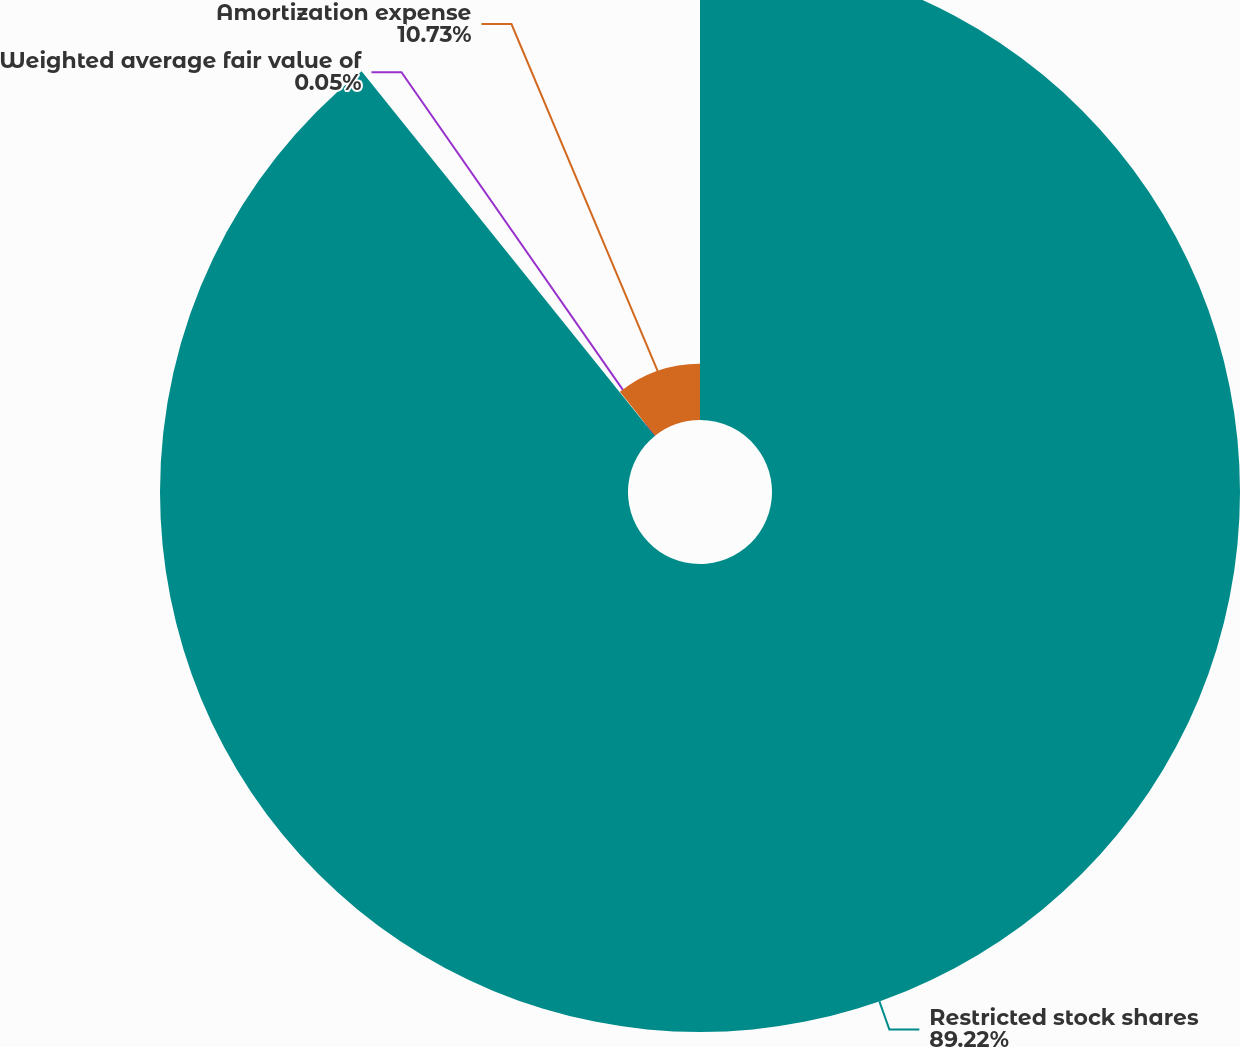Convert chart. <chart><loc_0><loc_0><loc_500><loc_500><pie_chart><fcel>Restricted stock shares<fcel>Weighted average fair value of<fcel>Amortization expense<nl><fcel>89.22%<fcel>0.05%<fcel>10.73%<nl></chart> 